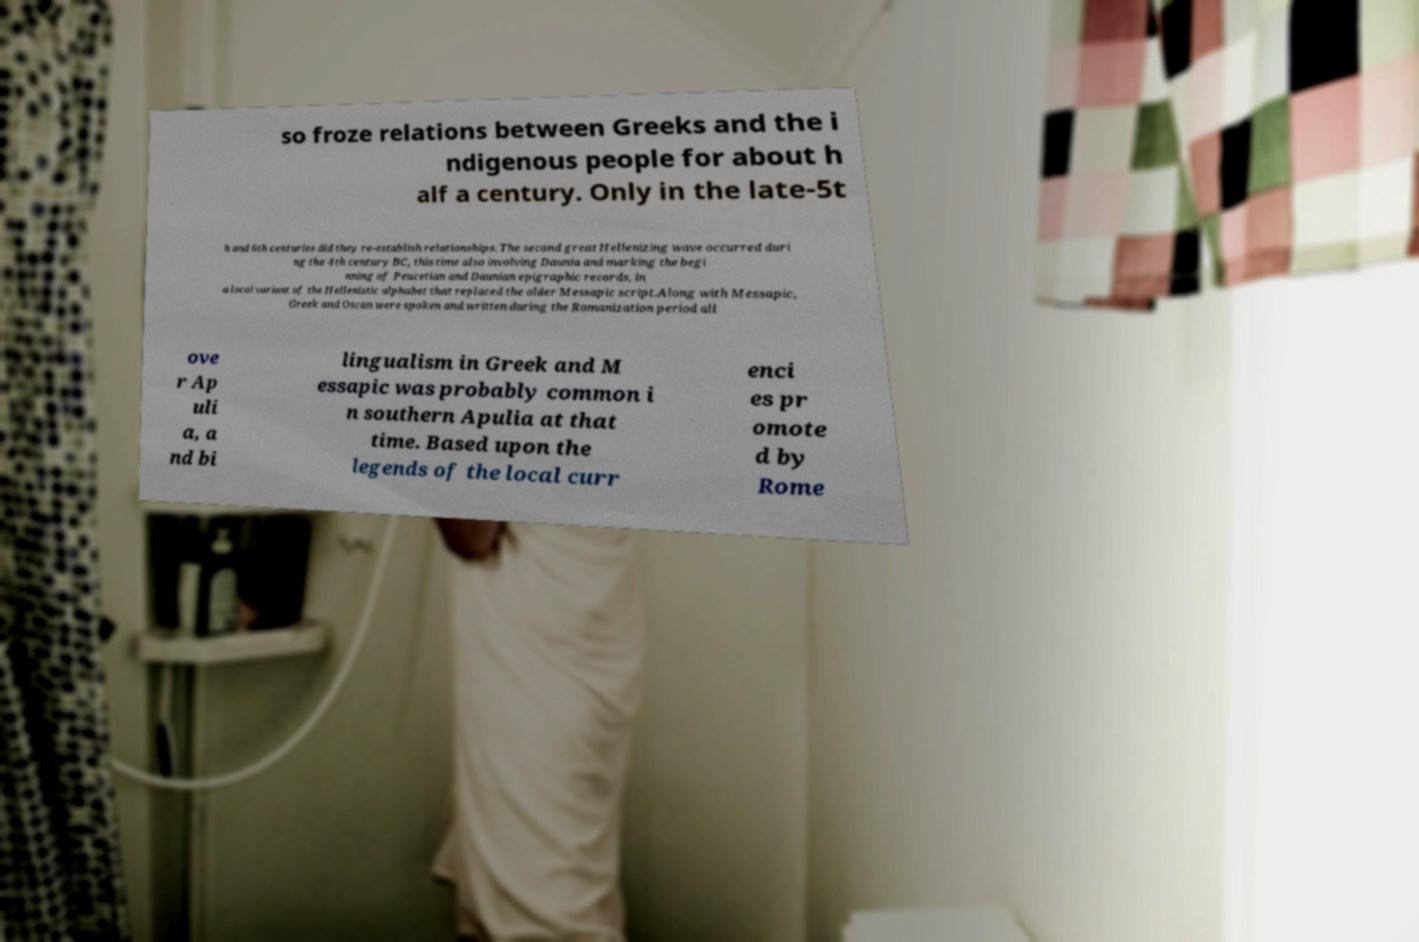Could you extract and type out the text from this image? so froze relations between Greeks and the i ndigenous people for about h alf a century. Only in the late-5t h and 6th centuries did they re-establish relationships. The second great Hellenizing wave occurred duri ng the 4th century BC, this time also involving Daunia and marking the begi nning of Peucetian and Daunian epigraphic records, in a local variant of the Hellenistic alphabet that replaced the older Messapic script.Along with Messapic, Greek and Oscan were spoken and written during the Romanization period all ove r Ap uli a, a nd bi lingualism in Greek and M essapic was probably common i n southern Apulia at that time. Based upon the legends of the local curr enci es pr omote d by Rome 